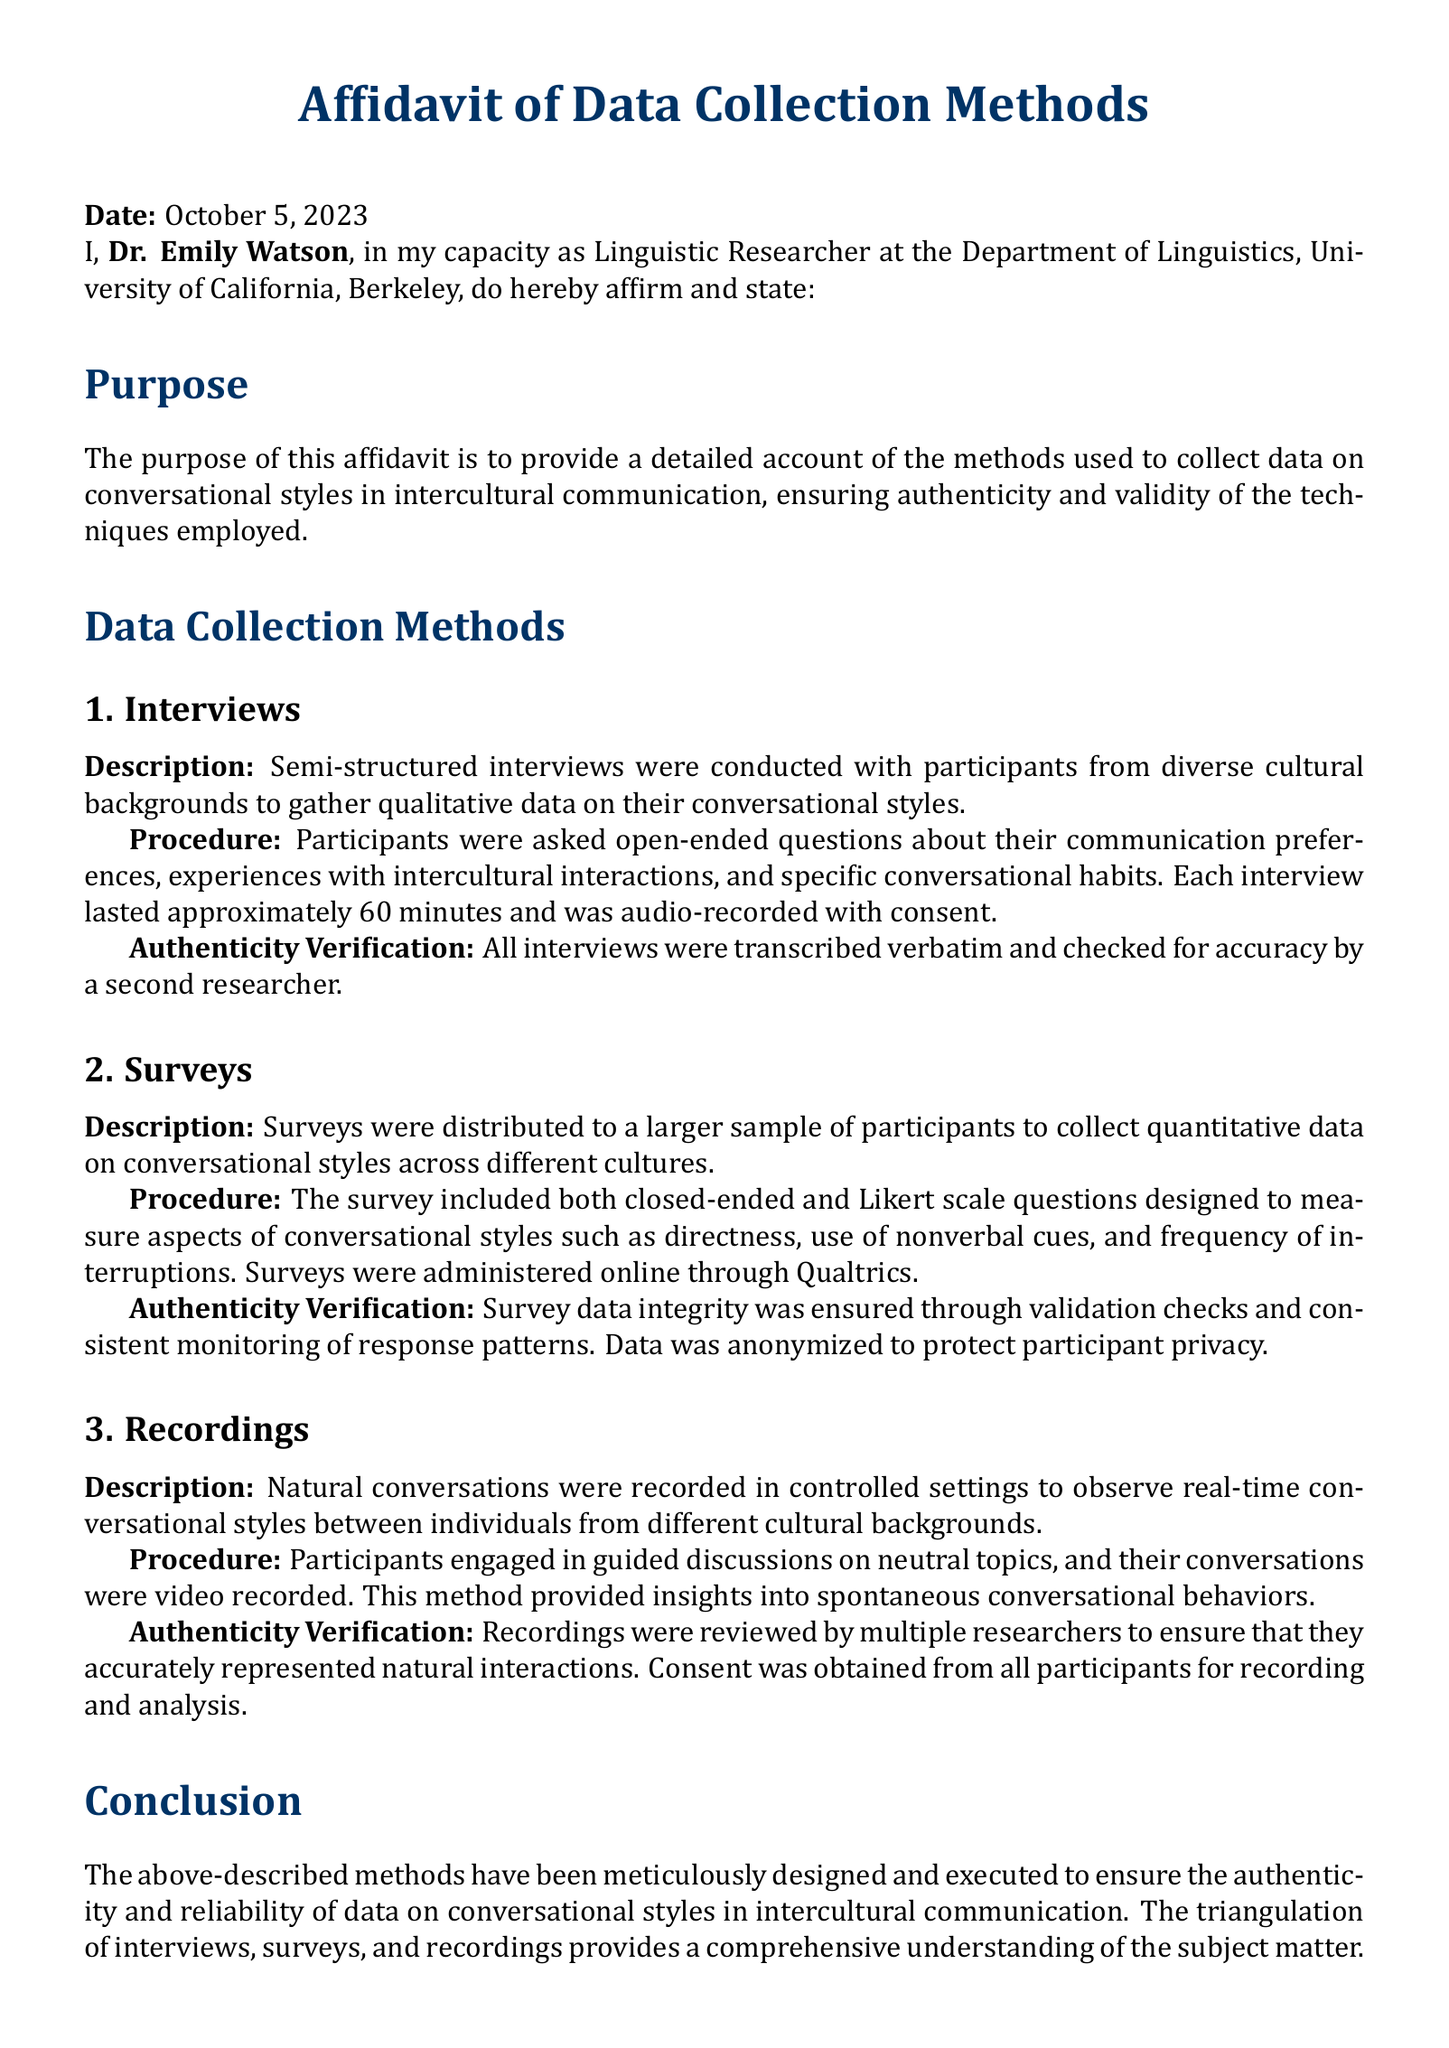What is the purpose of the affidavit? The affidavit's purpose is to provide a detailed account of the methods used to collect data on conversational styles in intercultural communication.
Answer: To provide a detailed account of the methods used to collect data on conversational styles in intercultural communication Who is the author of the affidavit? The author of the affidavit, as stated, is Dr. Emily Watson.
Answer: Dr. Emily Watson What is the date of the affidavit? The affidavit is dated October 5, 2023.
Answer: October 5, 2023 How long did each interview last? Each interview lasted approximately 60 minutes.
Answer: Approximately 60 minutes Which platform was used to administer surveys? The surveys were administered online through Qualtrics.
Answer: Qualtrics What type of questions were included in the surveys? The survey included closed-ended and Likert scale questions.
Answer: Closed-ended and Likert scale questions What verification method was used for the interviews? The interviews were transcribed verbatim and checked for accuracy by a second researcher.
Answer: Transcribed verbatim and checked for accuracy by a second researcher What was the primary focus of the recorded conversations? Participants engaged in guided discussions on neutral topics.
Answer: Guided discussions on neutral topics What approach was taken to ensure the integrity of survey data? Survey data integrity was ensured through validation checks and consistent monitoring of response patterns.
Answer: Validation checks and consistent monitoring of response patterns 